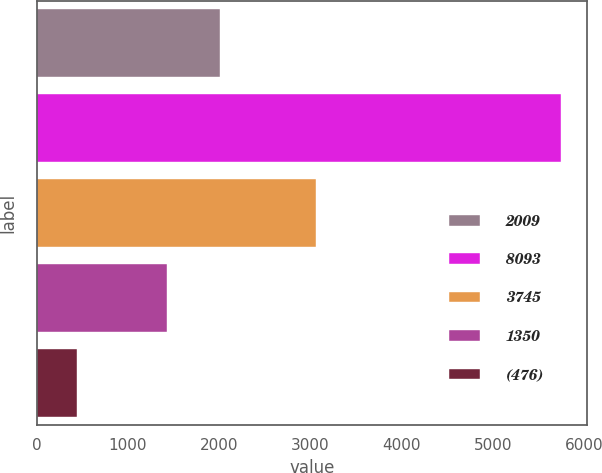Convert chart. <chart><loc_0><loc_0><loc_500><loc_500><bar_chart><fcel>2009<fcel>8093<fcel>3745<fcel>1350<fcel>(476)<nl><fcel>2007<fcel>5745<fcel>3061<fcel>1424<fcel>441<nl></chart> 